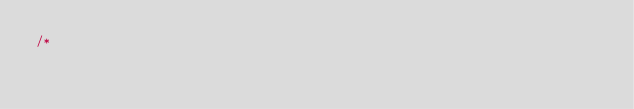<code> <loc_0><loc_0><loc_500><loc_500><_Kotlin_>/*</code> 